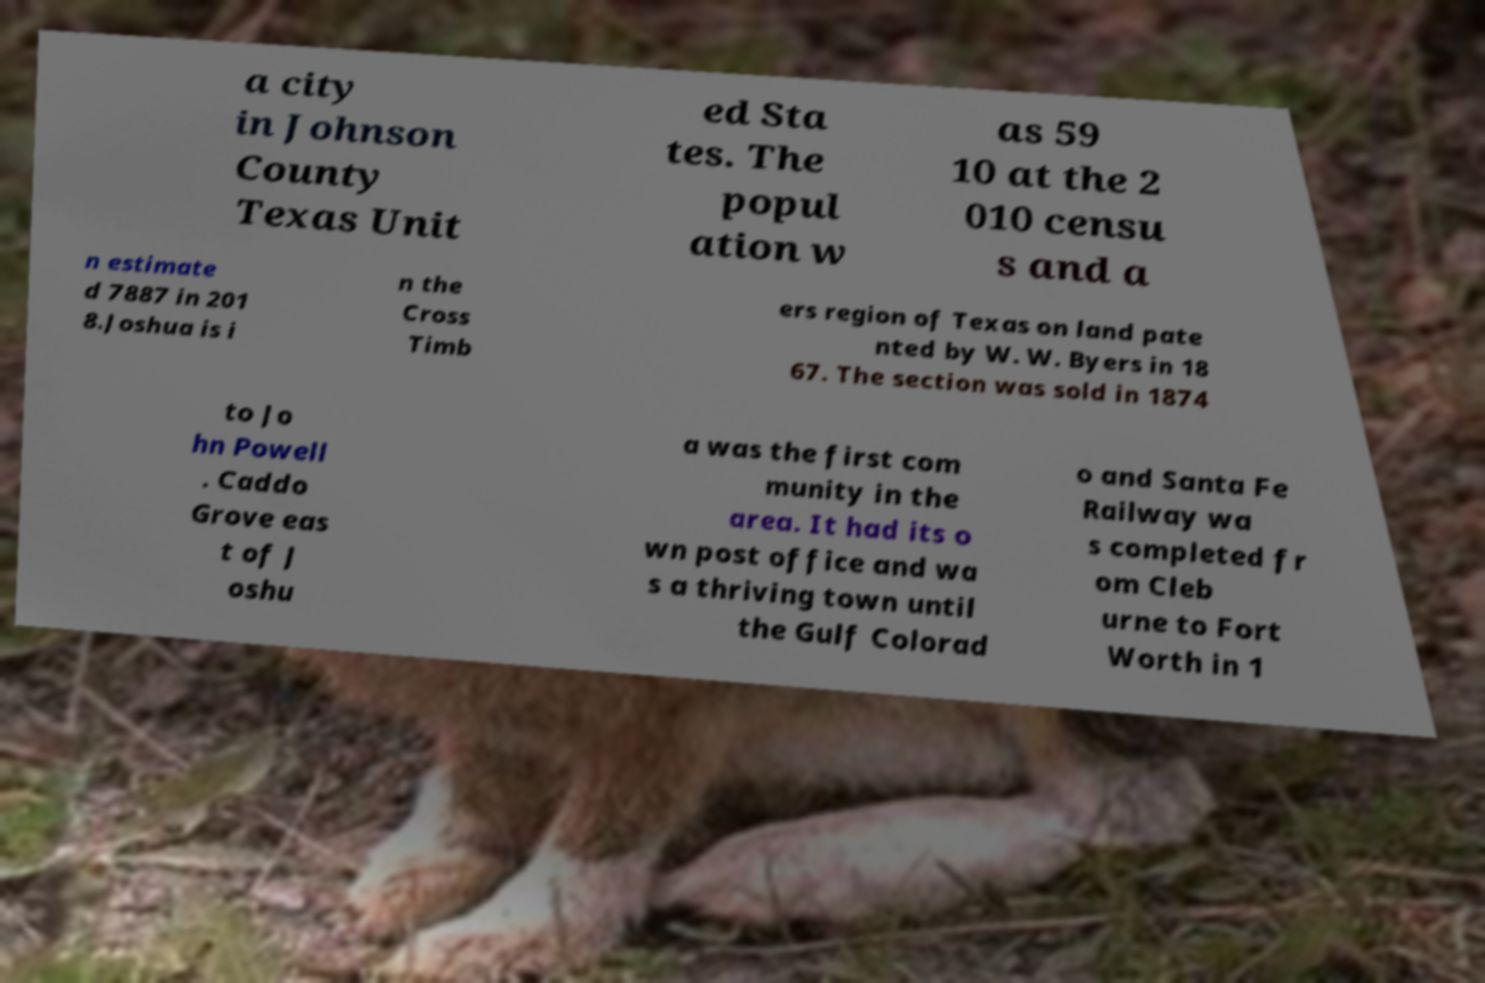What messages or text are displayed in this image? I need them in a readable, typed format. a city in Johnson County Texas Unit ed Sta tes. The popul ation w as 59 10 at the 2 010 censu s and a n estimate d 7887 in 201 8.Joshua is i n the Cross Timb ers region of Texas on land pate nted by W. W. Byers in 18 67. The section was sold in 1874 to Jo hn Powell . Caddo Grove eas t of J oshu a was the first com munity in the area. It had its o wn post office and wa s a thriving town until the Gulf Colorad o and Santa Fe Railway wa s completed fr om Cleb urne to Fort Worth in 1 